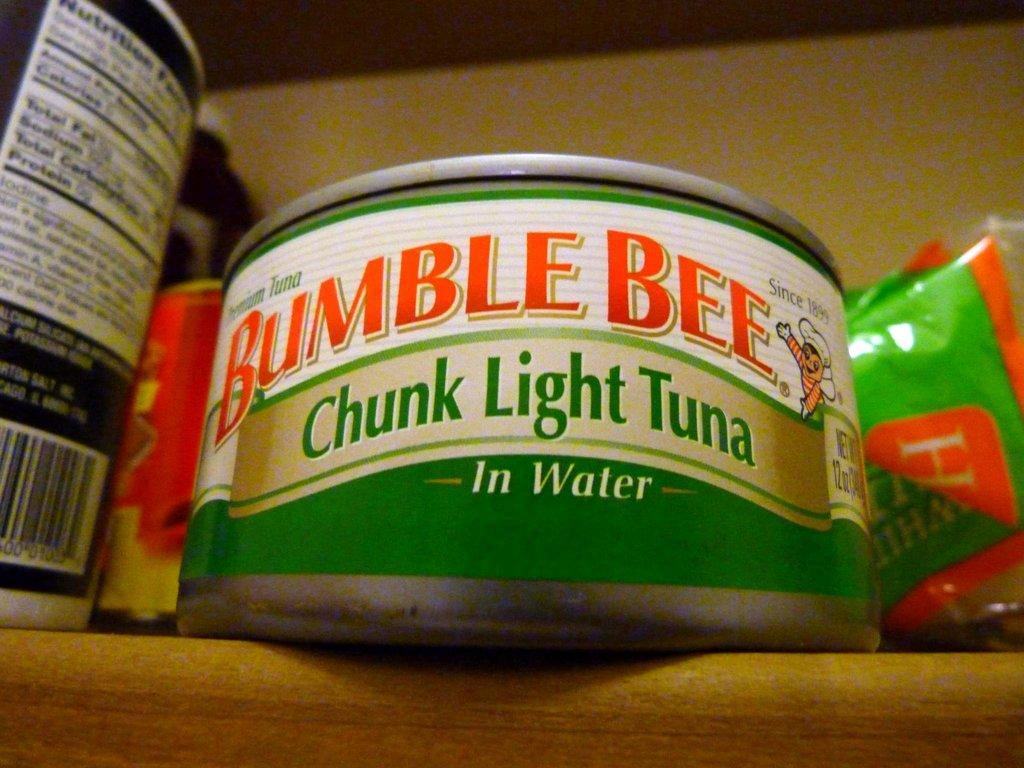Provide a one-sentence caption for the provided image. A shelf with a can of Bumble Bee chunk light tuna in water next to other food products. 